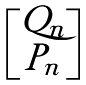<formula> <loc_0><loc_0><loc_500><loc_500>\begin{bmatrix} Q _ { n } \\ P _ { n } \end{bmatrix}</formula> 